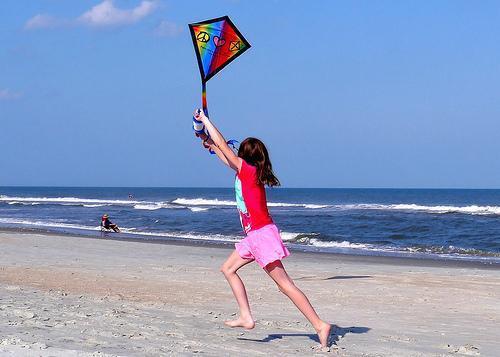How many people are pictured?
Give a very brief answer. 2. 